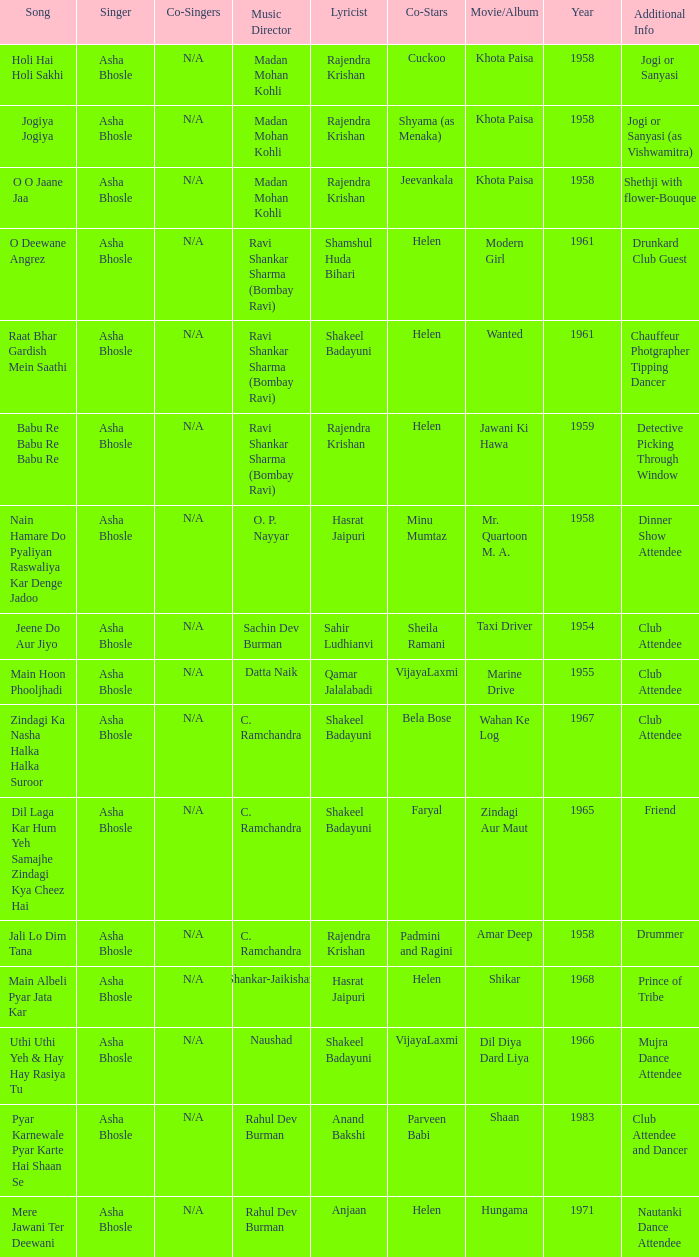Who sang for the movie Amar Deep? Asha Bhosle. 